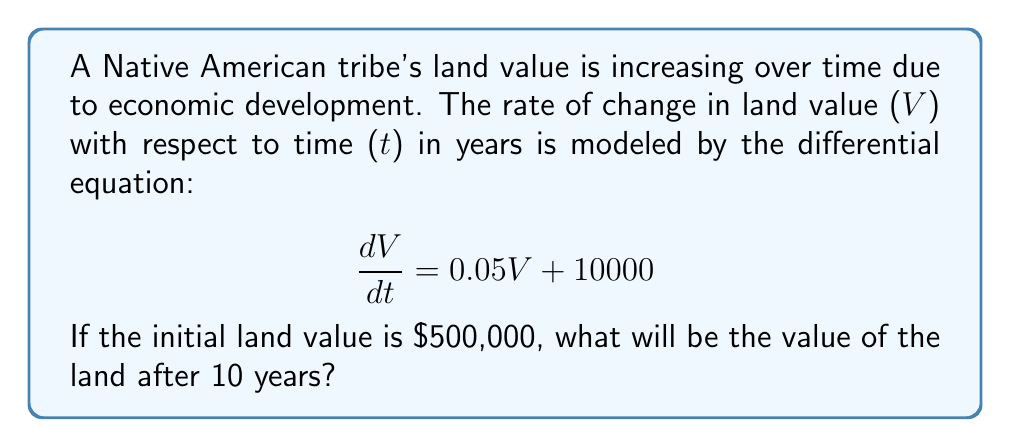Give your solution to this math problem. To solve this problem, we need to use the given differential equation and initial condition. Let's approach this step-by-step:

1) The differential equation is:

   $$\frac{dV}{dt} = 0.05V + 10000$$

2) This is a linear first-order differential equation of the form:

   $$\frac{dV}{dt} - 0.05V = 10000$$

3) We can solve this using the integrating factor method. The integrating factor is:

   $$\mu(t) = e^{-\int 0.05 dt} = e^{-0.05t}$$

4) Multiplying both sides of the equation by the integrating factor:

   $$e^{-0.05t}\frac{dV}{dt} - 0.05e^{-0.05t}V = 10000e^{-0.05t}$$

5) The left side is now the derivative of $e^{-0.05t}V$. So we can write:

   $$\frac{d}{dt}(e^{-0.05t}V) = 10000e^{-0.05t}$$

6) Integrating both sides:

   $$e^{-0.05t}V = -200000e^{-0.05t} + C$$

7) Solving for V:

   $$V = -200000 + Ce^{0.05t}$$

8) Using the initial condition V(0) = 500,000:

   $$500000 = -200000 + C$$
   $$C = 700000$$

9) Therefore, the general solution is:

   $$V(t) = -200000 + 700000e^{0.05t}$$

10) To find the value after 10 years, we substitute t = 10:

    $$V(10) = -200000 + 700000e^{0.5}$$

11) Calculating this value:

    $$V(10) = -200000 + 700000 \times 1.6487 = 954,090$$
Answer: The value of the land after 10 years will be approximately $954,090. 